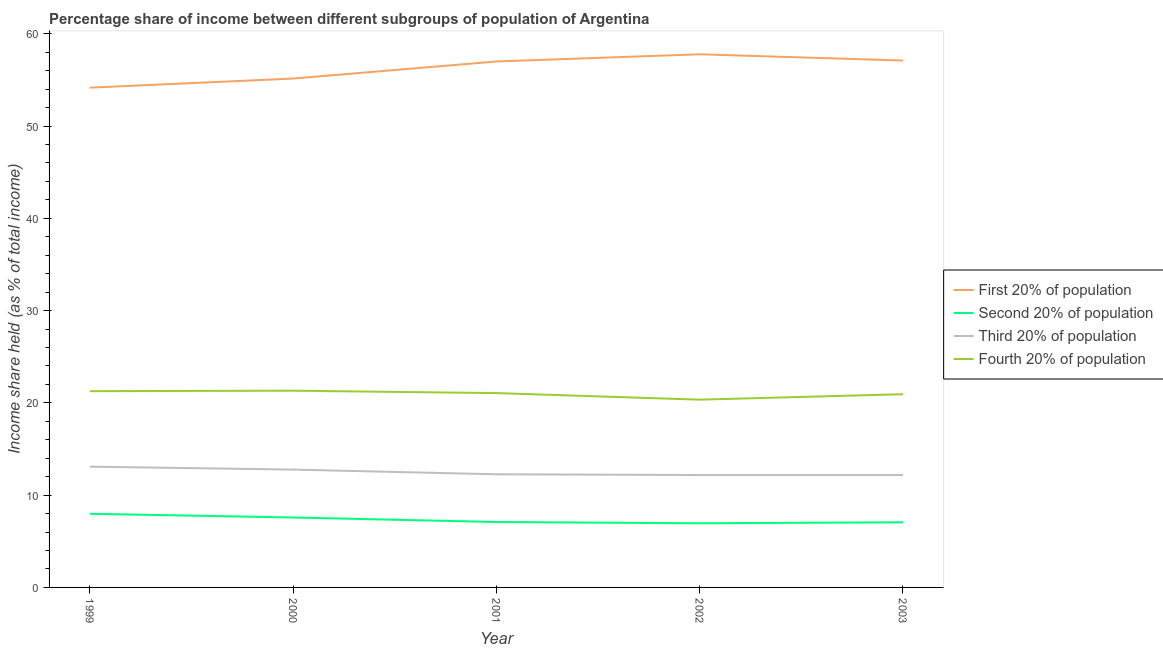How many different coloured lines are there?
Your answer should be very brief. 4. Does the line corresponding to share of the income held by first 20% of the population intersect with the line corresponding to share of the income held by third 20% of the population?
Your response must be concise. No. Is the number of lines equal to the number of legend labels?
Your answer should be compact. Yes. What is the share of the income held by fourth 20% of the population in 2000?
Offer a very short reply. 21.32. Across all years, what is the maximum share of the income held by first 20% of the population?
Offer a terse response. 57.78. Across all years, what is the minimum share of the income held by second 20% of the population?
Your answer should be very brief. 6.95. What is the total share of the income held by second 20% of the population in the graph?
Make the answer very short. 36.66. What is the difference between the share of the income held by second 20% of the population in 2000 and that in 2003?
Your response must be concise. 0.52. What is the difference between the share of the income held by second 20% of the population in 2002 and the share of the income held by first 20% of the population in 2000?
Provide a short and direct response. -48.2. What is the average share of the income held by third 20% of the population per year?
Make the answer very short. 12.5. In the year 2000, what is the difference between the share of the income held by third 20% of the population and share of the income held by second 20% of the population?
Offer a very short reply. 5.19. In how many years, is the share of the income held by fourth 20% of the population greater than 12 %?
Make the answer very short. 5. What is the ratio of the share of the income held by fourth 20% of the population in 2000 to that in 2001?
Give a very brief answer. 1.01. Is the share of the income held by first 20% of the population in 1999 less than that in 2000?
Offer a very short reply. Yes. Is the difference between the share of the income held by second 20% of the population in 2000 and 2001 greater than the difference between the share of the income held by first 20% of the population in 2000 and 2001?
Give a very brief answer. Yes. What is the difference between the highest and the second highest share of the income held by third 20% of the population?
Offer a terse response. 0.32. What is the difference between the highest and the lowest share of the income held by first 20% of the population?
Your answer should be very brief. 3.62. Is the share of the income held by fourth 20% of the population strictly less than the share of the income held by third 20% of the population over the years?
Your response must be concise. No. How many lines are there?
Make the answer very short. 4. What is the difference between two consecutive major ticks on the Y-axis?
Ensure brevity in your answer.  10. Are the values on the major ticks of Y-axis written in scientific E-notation?
Your answer should be very brief. No. Does the graph contain any zero values?
Your response must be concise. No. Where does the legend appear in the graph?
Your response must be concise. Center right. How are the legend labels stacked?
Provide a succinct answer. Vertical. What is the title of the graph?
Provide a short and direct response. Percentage share of income between different subgroups of population of Argentina. Does "France" appear as one of the legend labels in the graph?
Provide a succinct answer. No. What is the label or title of the Y-axis?
Your answer should be very brief. Income share held (as % of total income). What is the Income share held (as % of total income) in First 20% of population in 1999?
Provide a succinct answer. 54.16. What is the Income share held (as % of total income) of Second 20% of population in 1999?
Provide a succinct answer. 7.98. What is the Income share held (as % of total income) of Third 20% of population in 1999?
Make the answer very short. 13.09. What is the Income share held (as % of total income) in Fourth 20% of population in 1999?
Give a very brief answer. 21.27. What is the Income share held (as % of total income) of First 20% of population in 2000?
Your answer should be very brief. 55.15. What is the Income share held (as % of total income) in Second 20% of population in 2000?
Provide a succinct answer. 7.58. What is the Income share held (as % of total income) in Third 20% of population in 2000?
Ensure brevity in your answer.  12.77. What is the Income share held (as % of total income) in Fourth 20% of population in 2000?
Ensure brevity in your answer.  21.32. What is the Income share held (as % of total income) of Second 20% of population in 2001?
Ensure brevity in your answer.  7.09. What is the Income share held (as % of total income) of Third 20% of population in 2001?
Offer a very short reply. 12.26. What is the Income share held (as % of total income) in Fourth 20% of population in 2001?
Provide a short and direct response. 21.06. What is the Income share held (as % of total income) in First 20% of population in 2002?
Your answer should be very brief. 57.78. What is the Income share held (as % of total income) of Second 20% of population in 2002?
Make the answer very short. 6.95. What is the Income share held (as % of total income) in Third 20% of population in 2002?
Make the answer very short. 12.18. What is the Income share held (as % of total income) in Fourth 20% of population in 2002?
Provide a short and direct response. 20.35. What is the Income share held (as % of total income) of First 20% of population in 2003?
Provide a succinct answer. 57.1. What is the Income share held (as % of total income) of Second 20% of population in 2003?
Give a very brief answer. 7.06. What is the Income share held (as % of total income) in Third 20% of population in 2003?
Provide a succinct answer. 12.18. What is the Income share held (as % of total income) in Fourth 20% of population in 2003?
Provide a short and direct response. 20.94. Across all years, what is the maximum Income share held (as % of total income) of First 20% of population?
Ensure brevity in your answer.  57.78. Across all years, what is the maximum Income share held (as % of total income) in Second 20% of population?
Provide a short and direct response. 7.98. Across all years, what is the maximum Income share held (as % of total income) in Third 20% of population?
Your answer should be very brief. 13.09. Across all years, what is the maximum Income share held (as % of total income) of Fourth 20% of population?
Ensure brevity in your answer.  21.32. Across all years, what is the minimum Income share held (as % of total income) in First 20% of population?
Your answer should be compact. 54.16. Across all years, what is the minimum Income share held (as % of total income) of Second 20% of population?
Your answer should be very brief. 6.95. Across all years, what is the minimum Income share held (as % of total income) in Third 20% of population?
Your answer should be compact. 12.18. Across all years, what is the minimum Income share held (as % of total income) in Fourth 20% of population?
Provide a succinct answer. 20.35. What is the total Income share held (as % of total income) of First 20% of population in the graph?
Ensure brevity in your answer.  281.19. What is the total Income share held (as % of total income) of Second 20% of population in the graph?
Your answer should be compact. 36.66. What is the total Income share held (as % of total income) of Third 20% of population in the graph?
Your answer should be very brief. 62.48. What is the total Income share held (as % of total income) of Fourth 20% of population in the graph?
Ensure brevity in your answer.  104.94. What is the difference between the Income share held (as % of total income) of First 20% of population in 1999 and that in 2000?
Make the answer very short. -0.99. What is the difference between the Income share held (as % of total income) in Second 20% of population in 1999 and that in 2000?
Keep it short and to the point. 0.4. What is the difference between the Income share held (as % of total income) in Third 20% of population in 1999 and that in 2000?
Your answer should be compact. 0.32. What is the difference between the Income share held (as % of total income) of Fourth 20% of population in 1999 and that in 2000?
Give a very brief answer. -0.05. What is the difference between the Income share held (as % of total income) in First 20% of population in 1999 and that in 2001?
Keep it short and to the point. -2.84. What is the difference between the Income share held (as % of total income) in Second 20% of population in 1999 and that in 2001?
Provide a succinct answer. 0.89. What is the difference between the Income share held (as % of total income) in Third 20% of population in 1999 and that in 2001?
Your answer should be compact. 0.83. What is the difference between the Income share held (as % of total income) in Fourth 20% of population in 1999 and that in 2001?
Offer a very short reply. 0.21. What is the difference between the Income share held (as % of total income) of First 20% of population in 1999 and that in 2002?
Your answer should be compact. -3.62. What is the difference between the Income share held (as % of total income) of Third 20% of population in 1999 and that in 2002?
Your answer should be very brief. 0.91. What is the difference between the Income share held (as % of total income) in Fourth 20% of population in 1999 and that in 2002?
Provide a succinct answer. 0.92. What is the difference between the Income share held (as % of total income) of First 20% of population in 1999 and that in 2003?
Provide a short and direct response. -2.94. What is the difference between the Income share held (as % of total income) of Third 20% of population in 1999 and that in 2003?
Your answer should be very brief. 0.91. What is the difference between the Income share held (as % of total income) in Fourth 20% of population in 1999 and that in 2003?
Provide a short and direct response. 0.33. What is the difference between the Income share held (as % of total income) of First 20% of population in 2000 and that in 2001?
Provide a short and direct response. -1.85. What is the difference between the Income share held (as % of total income) in Second 20% of population in 2000 and that in 2001?
Make the answer very short. 0.49. What is the difference between the Income share held (as % of total income) in Third 20% of population in 2000 and that in 2001?
Give a very brief answer. 0.51. What is the difference between the Income share held (as % of total income) of Fourth 20% of population in 2000 and that in 2001?
Your answer should be compact. 0.26. What is the difference between the Income share held (as % of total income) in First 20% of population in 2000 and that in 2002?
Give a very brief answer. -2.63. What is the difference between the Income share held (as % of total income) of Second 20% of population in 2000 and that in 2002?
Provide a short and direct response. 0.63. What is the difference between the Income share held (as % of total income) of Third 20% of population in 2000 and that in 2002?
Your answer should be very brief. 0.59. What is the difference between the Income share held (as % of total income) in First 20% of population in 2000 and that in 2003?
Your answer should be compact. -1.95. What is the difference between the Income share held (as % of total income) of Second 20% of population in 2000 and that in 2003?
Keep it short and to the point. 0.52. What is the difference between the Income share held (as % of total income) in Third 20% of population in 2000 and that in 2003?
Your answer should be compact. 0.59. What is the difference between the Income share held (as % of total income) in Fourth 20% of population in 2000 and that in 2003?
Ensure brevity in your answer.  0.38. What is the difference between the Income share held (as % of total income) in First 20% of population in 2001 and that in 2002?
Make the answer very short. -0.78. What is the difference between the Income share held (as % of total income) of Second 20% of population in 2001 and that in 2002?
Your answer should be compact. 0.14. What is the difference between the Income share held (as % of total income) of Fourth 20% of population in 2001 and that in 2002?
Provide a short and direct response. 0.71. What is the difference between the Income share held (as % of total income) of First 20% of population in 2001 and that in 2003?
Offer a terse response. -0.1. What is the difference between the Income share held (as % of total income) in Second 20% of population in 2001 and that in 2003?
Ensure brevity in your answer.  0.03. What is the difference between the Income share held (as % of total income) in Fourth 20% of population in 2001 and that in 2003?
Provide a short and direct response. 0.12. What is the difference between the Income share held (as % of total income) of First 20% of population in 2002 and that in 2003?
Ensure brevity in your answer.  0.68. What is the difference between the Income share held (as % of total income) in Second 20% of population in 2002 and that in 2003?
Your response must be concise. -0.11. What is the difference between the Income share held (as % of total income) of Fourth 20% of population in 2002 and that in 2003?
Make the answer very short. -0.59. What is the difference between the Income share held (as % of total income) of First 20% of population in 1999 and the Income share held (as % of total income) of Second 20% of population in 2000?
Provide a short and direct response. 46.58. What is the difference between the Income share held (as % of total income) in First 20% of population in 1999 and the Income share held (as % of total income) in Third 20% of population in 2000?
Offer a terse response. 41.39. What is the difference between the Income share held (as % of total income) of First 20% of population in 1999 and the Income share held (as % of total income) of Fourth 20% of population in 2000?
Your response must be concise. 32.84. What is the difference between the Income share held (as % of total income) of Second 20% of population in 1999 and the Income share held (as % of total income) of Third 20% of population in 2000?
Offer a terse response. -4.79. What is the difference between the Income share held (as % of total income) in Second 20% of population in 1999 and the Income share held (as % of total income) in Fourth 20% of population in 2000?
Provide a short and direct response. -13.34. What is the difference between the Income share held (as % of total income) of Third 20% of population in 1999 and the Income share held (as % of total income) of Fourth 20% of population in 2000?
Keep it short and to the point. -8.23. What is the difference between the Income share held (as % of total income) of First 20% of population in 1999 and the Income share held (as % of total income) of Second 20% of population in 2001?
Ensure brevity in your answer.  47.07. What is the difference between the Income share held (as % of total income) of First 20% of population in 1999 and the Income share held (as % of total income) of Third 20% of population in 2001?
Offer a very short reply. 41.9. What is the difference between the Income share held (as % of total income) of First 20% of population in 1999 and the Income share held (as % of total income) of Fourth 20% of population in 2001?
Provide a succinct answer. 33.1. What is the difference between the Income share held (as % of total income) of Second 20% of population in 1999 and the Income share held (as % of total income) of Third 20% of population in 2001?
Give a very brief answer. -4.28. What is the difference between the Income share held (as % of total income) in Second 20% of population in 1999 and the Income share held (as % of total income) in Fourth 20% of population in 2001?
Keep it short and to the point. -13.08. What is the difference between the Income share held (as % of total income) in Third 20% of population in 1999 and the Income share held (as % of total income) in Fourth 20% of population in 2001?
Your response must be concise. -7.97. What is the difference between the Income share held (as % of total income) in First 20% of population in 1999 and the Income share held (as % of total income) in Second 20% of population in 2002?
Ensure brevity in your answer.  47.21. What is the difference between the Income share held (as % of total income) in First 20% of population in 1999 and the Income share held (as % of total income) in Third 20% of population in 2002?
Provide a short and direct response. 41.98. What is the difference between the Income share held (as % of total income) in First 20% of population in 1999 and the Income share held (as % of total income) in Fourth 20% of population in 2002?
Provide a succinct answer. 33.81. What is the difference between the Income share held (as % of total income) of Second 20% of population in 1999 and the Income share held (as % of total income) of Fourth 20% of population in 2002?
Your response must be concise. -12.37. What is the difference between the Income share held (as % of total income) in Third 20% of population in 1999 and the Income share held (as % of total income) in Fourth 20% of population in 2002?
Offer a very short reply. -7.26. What is the difference between the Income share held (as % of total income) in First 20% of population in 1999 and the Income share held (as % of total income) in Second 20% of population in 2003?
Provide a short and direct response. 47.1. What is the difference between the Income share held (as % of total income) in First 20% of population in 1999 and the Income share held (as % of total income) in Third 20% of population in 2003?
Your answer should be compact. 41.98. What is the difference between the Income share held (as % of total income) in First 20% of population in 1999 and the Income share held (as % of total income) in Fourth 20% of population in 2003?
Provide a succinct answer. 33.22. What is the difference between the Income share held (as % of total income) in Second 20% of population in 1999 and the Income share held (as % of total income) in Fourth 20% of population in 2003?
Make the answer very short. -12.96. What is the difference between the Income share held (as % of total income) of Third 20% of population in 1999 and the Income share held (as % of total income) of Fourth 20% of population in 2003?
Ensure brevity in your answer.  -7.85. What is the difference between the Income share held (as % of total income) in First 20% of population in 2000 and the Income share held (as % of total income) in Second 20% of population in 2001?
Your answer should be compact. 48.06. What is the difference between the Income share held (as % of total income) of First 20% of population in 2000 and the Income share held (as % of total income) of Third 20% of population in 2001?
Your response must be concise. 42.89. What is the difference between the Income share held (as % of total income) of First 20% of population in 2000 and the Income share held (as % of total income) of Fourth 20% of population in 2001?
Your answer should be compact. 34.09. What is the difference between the Income share held (as % of total income) of Second 20% of population in 2000 and the Income share held (as % of total income) of Third 20% of population in 2001?
Your answer should be very brief. -4.68. What is the difference between the Income share held (as % of total income) of Second 20% of population in 2000 and the Income share held (as % of total income) of Fourth 20% of population in 2001?
Your answer should be compact. -13.48. What is the difference between the Income share held (as % of total income) in Third 20% of population in 2000 and the Income share held (as % of total income) in Fourth 20% of population in 2001?
Offer a terse response. -8.29. What is the difference between the Income share held (as % of total income) in First 20% of population in 2000 and the Income share held (as % of total income) in Second 20% of population in 2002?
Provide a succinct answer. 48.2. What is the difference between the Income share held (as % of total income) of First 20% of population in 2000 and the Income share held (as % of total income) of Third 20% of population in 2002?
Ensure brevity in your answer.  42.97. What is the difference between the Income share held (as % of total income) of First 20% of population in 2000 and the Income share held (as % of total income) of Fourth 20% of population in 2002?
Your answer should be compact. 34.8. What is the difference between the Income share held (as % of total income) of Second 20% of population in 2000 and the Income share held (as % of total income) of Third 20% of population in 2002?
Your answer should be compact. -4.6. What is the difference between the Income share held (as % of total income) in Second 20% of population in 2000 and the Income share held (as % of total income) in Fourth 20% of population in 2002?
Provide a succinct answer. -12.77. What is the difference between the Income share held (as % of total income) in Third 20% of population in 2000 and the Income share held (as % of total income) in Fourth 20% of population in 2002?
Keep it short and to the point. -7.58. What is the difference between the Income share held (as % of total income) in First 20% of population in 2000 and the Income share held (as % of total income) in Second 20% of population in 2003?
Provide a succinct answer. 48.09. What is the difference between the Income share held (as % of total income) of First 20% of population in 2000 and the Income share held (as % of total income) of Third 20% of population in 2003?
Provide a short and direct response. 42.97. What is the difference between the Income share held (as % of total income) in First 20% of population in 2000 and the Income share held (as % of total income) in Fourth 20% of population in 2003?
Your answer should be very brief. 34.21. What is the difference between the Income share held (as % of total income) in Second 20% of population in 2000 and the Income share held (as % of total income) in Fourth 20% of population in 2003?
Offer a very short reply. -13.36. What is the difference between the Income share held (as % of total income) of Third 20% of population in 2000 and the Income share held (as % of total income) of Fourth 20% of population in 2003?
Keep it short and to the point. -8.17. What is the difference between the Income share held (as % of total income) of First 20% of population in 2001 and the Income share held (as % of total income) of Second 20% of population in 2002?
Your answer should be very brief. 50.05. What is the difference between the Income share held (as % of total income) in First 20% of population in 2001 and the Income share held (as % of total income) in Third 20% of population in 2002?
Provide a succinct answer. 44.82. What is the difference between the Income share held (as % of total income) in First 20% of population in 2001 and the Income share held (as % of total income) in Fourth 20% of population in 2002?
Provide a succinct answer. 36.65. What is the difference between the Income share held (as % of total income) in Second 20% of population in 2001 and the Income share held (as % of total income) in Third 20% of population in 2002?
Provide a succinct answer. -5.09. What is the difference between the Income share held (as % of total income) in Second 20% of population in 2001 and the Income share held (as % of total income) in Fourth 20% of population in 2002?
Your response must be concise. -13.26. What is the difference between the Income share held (as % of total income) in Third 20% of population in 2001 and the Income share held (as % of total income) in Fourth 20% of population in 2002?
Give a very brief answer. -8.09. What is the difference between the Income share held (as % of total income) in First 20% of population in 2001 and the Income share held (as % of total income) in Second 20% of population in 2003?
Your response must be concise. 49.94. What is the difference between the Income share held (as % of total income) in First 20% of population in 2001 and the Income share held (as % of total income) in Third 20% of population in 2003?
Keep it short and to the point. 44.82. What is the difference between the Income share held (as % of total income) in First 20% of population in 2001 and the Income share held (as % of total income) in Fourth 20% of population in 2003?
Provide a succinct answer. 36.06. What is the difference between the Income share held (as % of total income) in Second 20% of population in 2001 and the Income share held (as % of total income) in Third 20% of population in 2003?
Ensure brevity in your answer.  -5.09. What is the difference between the Income share held (as % of total income) in Second 20% of population in 2001 and the Income share held (as % of total income) in Fourth 20% of population in 2003?
Ensure brevity in your answer.  -13.85. What is the difference between the Income share held (as % of total income) of Third 20% of population in 2001 and the Income share held (as % of total income) of Fourth 20% of population in 2003?
Give a very brief answer. -8.68. What is the difference between the Income share held (as % of total income) in First 20% of population in 2002 and the Income share held (as % of total income) in Second 20% of population in 2003?
Keep it short and to the point. 50.72. What is the difference between the Income share held (as % of total income) of First 20% of population in 2002 and the Income share held (as % of total income) of Third 20% of population in 2003?
Ensure brevity in your answer.  45.6. What is the difference between the Income share held (as % of total income) of First 20% of population in 2002 and the Income share held (as % of total income) of Fourth 20% of population in 2003?
Provide a short and direct response. 36.84. What is the difference between the Income share held (as % of total income) in Second 20% of population in 2002 and the Income share held (as % of total income) in Third 20% of population in 2003?
Your answer should be very brief. -5.23. What is the difference between the Income share held (as % of total income) of Second 20% of population in 2002 and the Income share held (as % of total income) of Fourth 20% of population in 2003?
Your answer should be very brief. -13.99. What is the difference between the Income share held (as % of total income) in Third 20% of population in 2002 and the Income share held (as % of total income) in Fourth 20% of population in 2003?
Offer a terse response. -8.76. What is the average Income share held (as % of total income) in First 20% of population per year?
Provide a short and direct response. 56.24. What is the average Income share held (as % of total income) of Second 20% of population per year?
Your answer should be compact. 7.33. What is the average Income share held (as % of total income) in Third 20% of population per year?
Your answer should be very brief. 12.5. What is the average Income share held (as % of total income) of Fourth 20% of population per year?
Ensure brevity in your answer.  20.99. In the year 1999, what is the difference between the Income share held (as % of total income) of First 20% of population and Income share held (as % of total income) of Second 20% of population?
Offer a very short reply. 46.18. In the year 1999, what is the difference between the Income share held (as % of total income) in First 20% of population and Income share held (as % of total income) in Third 20% of population?
Offer a terse response. 41.07. In the year 1999, what is the difference between the Income share held (as % of total income) of First 20% of population and Income share held (as % of total income) of Fourth 20% of population?
Keep it short and to the point. 32.89. In the year 1999, what is the difference between the Income share held (as % of total income) in Second 20% of population and Income share held (as % of total income) in Third 20% of population?
Provide a short and direct response. -5.11. In the year 1999, what is the difference between the Income share held (as % of total income) in Second 20% of population and Income share held (as % of total income) in Fourth 20% of population?
Offer a terse response. -13.29. In the year 1999, what is the difference between the Income share held (as % of total income) of Third 20% of population and Income share held (as % of total income) of Fourth 20% of population?
Make the answer very short. -8.18. In the year 2000, what is the difference between the Income share held (as % of total income) in First 20% of population and Income share held (as % of total income) in Second 20% of population?
Keep it short and to the point. 47.57. In the year 2000, what is the difference between the Income share held (as % of total income) in First 20% of population and Income share held (as % of total income) in Third 20% of population?
Give a very brief answer. 42.38. In the year 2000, what is the difference between the Income share held (as % of total income) of First 20% of population and Income share held (as % of total income) of Fourth 20% of population?
Provide a short and direct response. 33.83. In the year 2000, what is the difference between the Income share held (as % of total income) in Second 20% of population and Income share held (as % of total income) in Third 20% of population?
Keep it short and to the point. -5.19. In the year 2000, what is the difference between the Income share held (as % of total income) in Second 20% of population and Income share held (as % of total income) in Fourth 20% of population?
Keep it short and to the point. -13.74. In the year 2000, what is the difference between the Income share held (as % of total income) in Third 20% of population and Income share held (as % of total income) in Fourth 20% of population?
Your response must be concise. -8.55. In the year 2001, what is the difference between the Income share held (as % of total income) in First 20% of population and Income share held (as % of total income) in Second 20% of population?
Provide a short and direct response. 49.91. In the year 2001, what is the difference between the Income share held (as % of total income) of First 20% of population and Income share held (as % of total income) of Third 20% of population?
Give a very brief answer. 44.74. In the year 2001, what is the difference between the Income share held (as % of total income) of First 20% of population and Income share held (as % of total income) of Fourth 20% of population?
Your answer should be compact. 35.94. In the year 2001, what is the difference between the Income share held (as % of total income) in Second 20% of population and Income share held (as % of total income) in Third 20% of population?
Provide a succinct answer. -5.17. In the year 2001, what is the difference between the Income share held (as % of total income) in Second 20% of population and Income share held (as % of total income) in Fourth 20% of population?
Keep it short and to the point. -13.97. In the year 2002, what is the difference between the Income share held (as % of total income) of First 20% of population and Income share held (as % of total income) of Second 20% of population?
Offer a very short reply. 50.83. In the year 2002, what is the difference between the Income share held (as % of total income) in First 20% of population and Income share held (as % of total income) in Third 20% of population?
Your answer should be compact. 45.6. In the year 2002, what is the difference between the Income share held (as % of total income) of First 20% of population and Income share held (as % of total income) of Fourth 20% of population?
Provide a short and direct response. 37.43. In the year 2002, what is the difference between the Income share held (as % of total income) of Second 20% of population and Income share held (as % of total income) of Third 20% of population?
Provide a short and direct response. -5.23. In the year 2002, what is the difference between the Income share held (as % of total income) in Third 20% of population and Income share held (as % of total income) in Fourth 20% of population?
Offer a terse response. -8.17. In the year 2003, what is the difference between the Income share held (as % of total income) of First 20% of population and Income share held (as % of total income) of Second 20% of population?
Ensure brevity in your answer.  50.04. In the year 2003, what is the difference between the Income share held (as % of total income) in First 20% of population and Income share held (as % of total income) in Third 20% of population?
Your answer should be compact. 44.92. In the year 2003, what is the difference between the Income share held (as % of total income) in First 20% of population and Income share held (as % of total income) in Fourth 20% of population?
Provide a short and direct response. 36.16. In the year 2003, what is the difference between the Income share held (as % of total income) in Second 20% of population and Income share held (as % of total income) in Third 20% of population?
Your response must be concise. -5.12. In the year 2003, what is the difference between the Income share held (as % of total income) of Second 20% of population and Income share held (as % of total income) of Fourth 20% of population?
Your answer should be compact. -13.88. In the year 2003, what is the difference between the Income share held (as % of total income) in Third 20% of population and Income share held (as % of total income) in Fourth 20% of population?
Make the answer very short. -8.76. What is the ratio of the Income share held (as % of total income) in First 20% of population in 1999 to that in 2000?
Keep it short and to the point. 0.98. What is the ratio of the Income share held (as % of total income) in Second 20% of population in 1999 to that in 2000?
Your answer should be compact. 1.05. What is the ratio of the Income share held (as % of total income) of Third 20% of population in 1999 to that in 2000?
Your answer should be very brief. 1.03. What is the ratio of the Income share held (as % of total income) in Fourth 20% of population in 1999 to that in 2000?
Your response must be concise. 1. What is the ratio of the Income share held (as % of total income) in First 20% of population in 1999 to that in 2001?
Your answer should be compact. 0.95. What is the ratio of the Income share held (as % of total income) in Second 20% of population in 1999 to that in 2001?
Make the answer very short. 1.13. What is the ratio of the Income share held (as % of total income) in Third 20% of population in 1999 to that in 2001?
Offer a terse response. 1.07. What is the ratio of the Income share held (as % of total income) in Fourth 20% of population in 1999 to that in 2001?
Ensure brevity in your answer.  1.01. What is the ratio of the Income share held (as % of total income) in First 20% of population in 1999 to that in 2002?
Ensure brevity in your answer.  0.94. What is the ratio of the Income share held (as % of total income) in Second 20% of population in 1999 to that in 2002?
Offer a terse response. 1.15. What is the ratio of the Income share held (as % of total income) in Third 20% of population in 1999 to that in 2002?
Provide a succinct answer. 1.07. What is the ratio of the Income share held (as % of total income) of Fourth 20% of population in 1999 to that in 2002?
Keep it short and to the point. 1.05. What is the ratio of the Income share held (as % of total income) in First 20% of population in 1999 to that in 2003?
Your response must be concise. 0.95. What is the ratio of the Income share held (as % of total income) of Second 20% of population in 1999 to that in 2003?
Your answer should be very brief. 1.13. What is the ratio of the Income share held (as % of total income) in Third 20% of population in 1999 to that in 2003?
Your answer should be compact. 1.07. What is the ratio of the Income share held (as % of total income) in Fourth 20% of population in 1999 to that in 2003?
Your answer should be very brief. 1.02. What is the ratio of the Income share held (as % of total income) in First 20% of population in 2000 to that in 2001?
Offer a terse response. 0.97. What is the ratio of the Income share held (as % of total income) in Second 20% of population in 2000 to that in 2001?
Make the answer very short. 1.07. What is the ratio of the Income share held (as % of total income) in Third 20% of population in 2000 to that in 2001?
Provide a short and direct response. 1.04. What is the ratio of the Income share held (as % of total income) in Fourth 20% of population in 2000 to that in 2001?
Your answer should be very brief. 1.01. What is the ratio of the Income share held (as % of total income) in First 20% of population in 2000 to that in 2002?
Ensure brevity in your answer.  0.95. What is the ratio of the Income share held (as % of total income) in Second 20% of population in 2000 to that in 2002?
Offer a terse response. 1.09. What is the ratio of the Income share held (as % of total income) of Third 20% of population in 2000 to that in 2002?
Keep it short and to the point. 1.05. What is the ratio of the Income share held (as % of total income) of Fourth 20% of population in 2000 to that in 2002?
Your response must be concise. 1.05. What is the ratio of the Income share held (as % of total income) in First 20% of population in 2000 to that in 2003?
Provide a succinct answer. 0.97. What is the ratio of the Income share held (as % of total income) of Second 20% of population in 2000 to that in 2003?
Your response must be concise. 1.07. What is the ratio of the Income share held (as % of total income) in Third 20% of population in 2000 to that in 2003?
Your response must be concise. 1.05. What is the ratio of the Income share held (as % of total income) in Fourth 20% of population in 2000 to that in 2003?
Provide a succinct answer. 1.02. What is the ratio of the Income share held (as % of total income) in First 20% of population in 2001 to that in 2002?
Ensure brevity in your answer.  0.99. What is the ratio of the Income share held (as % of total income) in Second 20% of population in 2001 to that in 2002?
Offer a terse response. 1.02. What is the ratio of the Income share held (as % of total income) of Third 20% of population in 2001 to that in 2002?
Offer a terse response. 1.01. What is the ratio of the Income share held (as % of total income) of Fourth 20% of population in 2001 to that in 2002?
Provide a succinct answer. 1.03. What is the ratio of the Income share held (as % of total income) in Second 20% of population in 2001 to that in 2003?
Give a very brief answer. 1. What is the ratio of the Income share held (as % of total income) of Third 20% of population in 2001 to that in 2003?
Your response must be concise. 1.01. What is the ratio of the Income share held (as % of total income) in First 20% of population in 2002 to that in 2003?
Offer a very short reply. 1.01. What is the ratio of the Income share held (as % of total income) of Second 20% of population in 2002 to that in 2003?
Provide a short and direct response. 0.98. What is the ratio of the Income share held (as % of total income) of Third 20% of population in 2002 to that in 2003?
Offer a terse response. 1. What is the ratio of the Income share held (as % of total income) of Fourth 20% of population in 2002 to that in 2003?
Provide a succinct answer. 0.97. What is the difference between the highest and the second highest Income share held (as % of total income) in First 20% of population?
Your response must be concise. 0.68. What is the difference between the highest and the second highest Income share held (as % of total income) in Second 20% of population?
Give a very brief answer. 0.4. What is the difference between the highest and the second highest Income share held (as % of total income) in Third 20% of population?
Ensure brevity in your answer.  0.32. What is the difference between the highest and the second highest Income share held (as % of total income) of Fourth 20% of population?
Provide a succinct answer. 0.05. What is the difference between the highest and the lowest Income share held (as % of total income) of First 20% of population?
Give a very brief answer. 3.62. What is the difference between the highest and the lowest Income share held (as % of total income) in Second 20% of population?
Provide a succinct answer. 1.03. What is the difference between the highest and the lowest Income share held (as % of total income) in Third 20% of population?
Give a very brief answer. 0.91. What is the difference between the highest and the lowest Income share held (as % of total income) in Fourth 20% of population?
Provide a succinct answer. 0.97. 